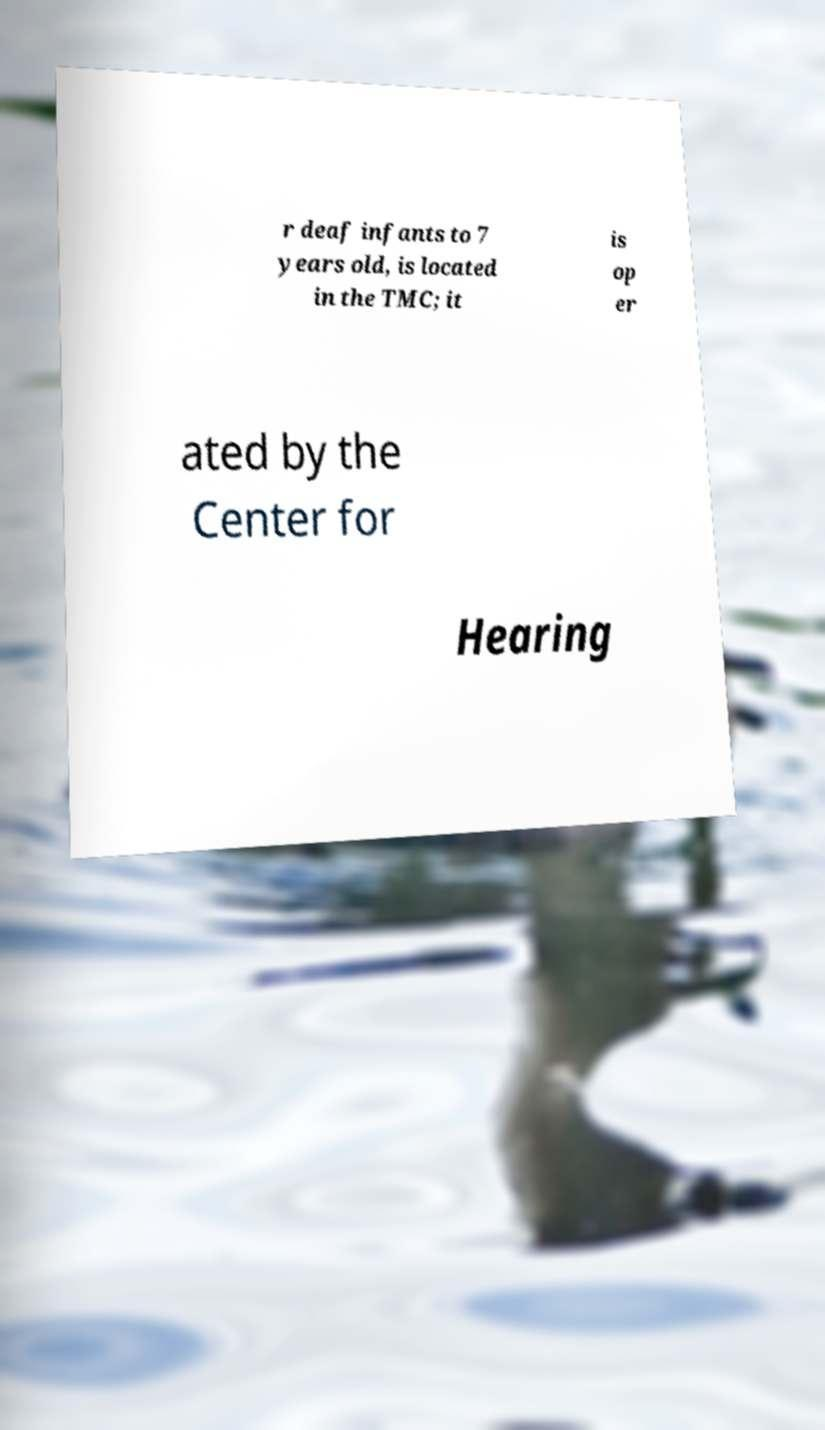Please identify and transcribe the text found in this image. r deaf infants to 7 years old, is located in the TMC; it is op er ated by the Center for Hearing 